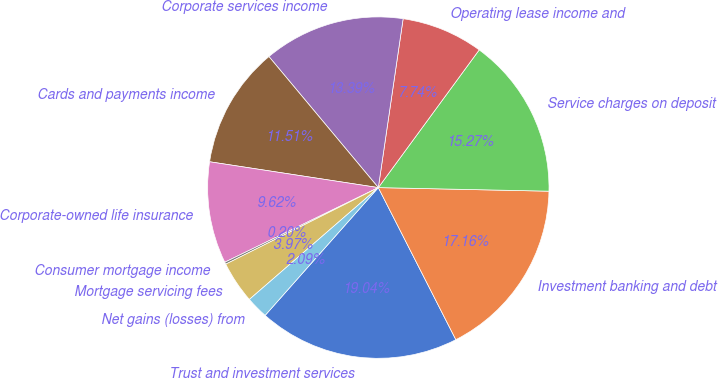Convert chart to OTSL. <chart><loc_0><loc_0><loc_500><loc_500><pie_chart><fcel>Trust and investment services<fcel>Investment banking and debt<fcel>Service charges on deposit<fcel>Operating lease income and<fcel>Corporate services income<fcel>Cards and payments income<fcel>Corporate-owned life insurance<fcel>Consumer mortgage income<fcel>Mortgage servicing fees<fcel>Net gains (losses) from<nl><fcel>19.04%<fcel>17.16%<fcel>15.27%<fcel>7.74%<fcel>13.39%<fcel>11.51%<fcel>9.62%<fcel>0.2%<fcel>3.97%<fcel>2.09%<nl></chart> 